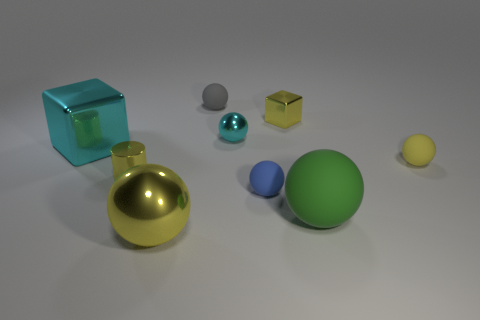What is the material of the sphere that is to the left of the small matte object that is behind the tiny yellow sphere?
Keep it short and to the point. Metal. Are there any other balls made of the same material as the tiny blue sphere?
Provide a succinct answer. Yes. There is a cyan sphere that is the same size as the yellow cube; what is it made of?
Ensure brevity in your answer.  Metal. What is the size of the yellow sphere that is in front of the small yellow shiny thing that is in front of the cyan metallic thing that is on the right side of the gray rubber sphere?
Provide a succinct answer. Large. There is a tiny metallic object that is in front of the cyan cube; is there a tiny yellow object that is right of it?
Offer a very short reply. Yes. Do the tiny yellow matte object and the tiny yellow object that is on the left side of the big yellow shiny ball have the same shape?
Provide a succinct answer. No. The tiny matte object right of the large green ball is what color?
Offer a very short reply. Yellow. There is a ball behind the cube behind the cyan metallic sphere; what is its size?
Keep it short and to the point. Small. There is a tiny shiny thing that is behind the small cyan object; does it have the same shape as the tiny blue rubber thing?
Offer a very short reply. No. What is the material of the other big thing that is the same shape as the large green thing?
Your response must be concise. Metal. 